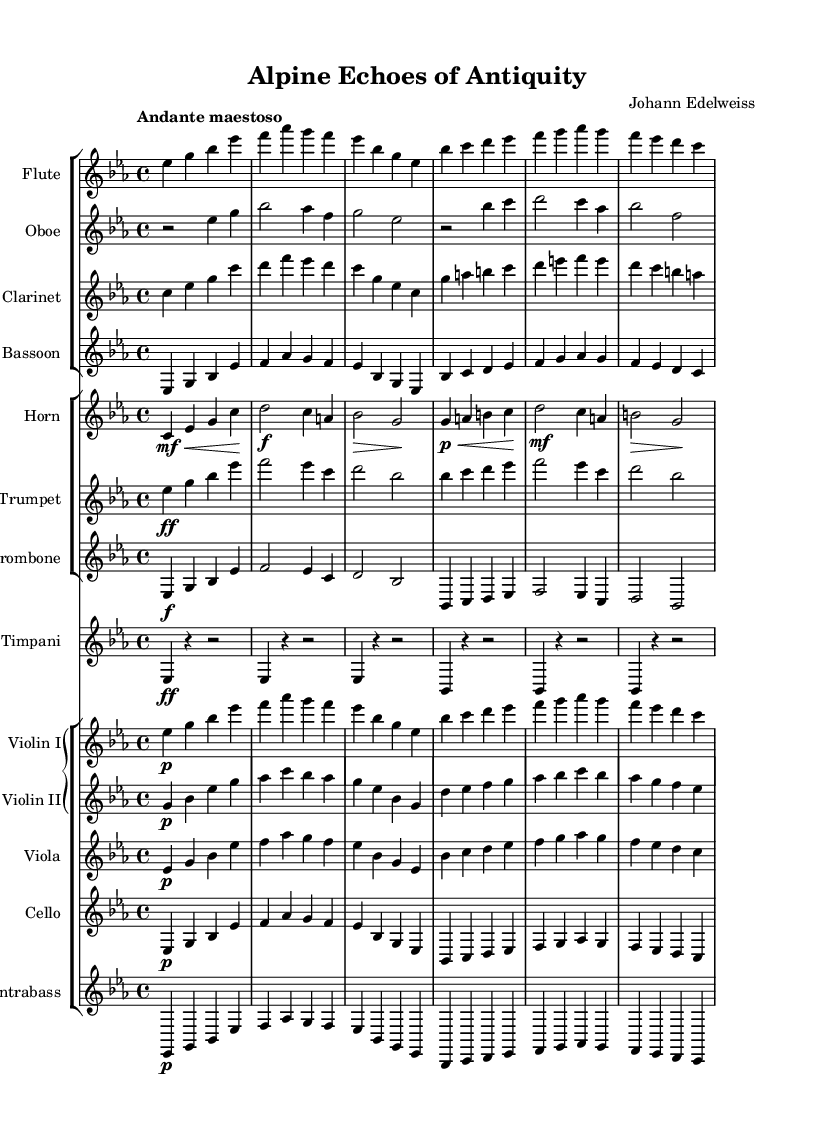What is the key signature of this music? The key signature is E-flat major, which is indicated by three flat notes (B-flat, E-flat, and A-flat) visible at the start of the staff.
Answer: E-flat major What is the time signature of this music? The time signature is 4/4, which is represented in the initial measure as a fractional notation indicating four beats per measure with a quarter note getting one beat.
Answer: 4/4 What is the tempo marking for this piece? The tempo marking is "Andante maestoso," which suggests a moderately slow tempo with a majestic character, noted above the score.
Answer: Andante maestoso How many different instruments are used in this score? There are a total of 12 different instruments indicated by the staff groups, each labeled accordingly.
Answer: 12 Which instrument has the highest part in the score? The instrument with the highest part is the Flute, based on the clef and the range of notes compared to other instruments.
Answer: Flute Which instruments are in the woodwind section? The woodwind section consists of Flute, Oboe, Clarinet, and Bassoon, identified in their respective groups in the score layout.
Answer: Flute, Oboe, Clarinet, Bassoon What is the lowest instrument in this score? The lowest instrument is the Contrabass, which is positioned in the lowest staff below the other string instruments, reflecting its deeper range.
Answer: Contrabass 